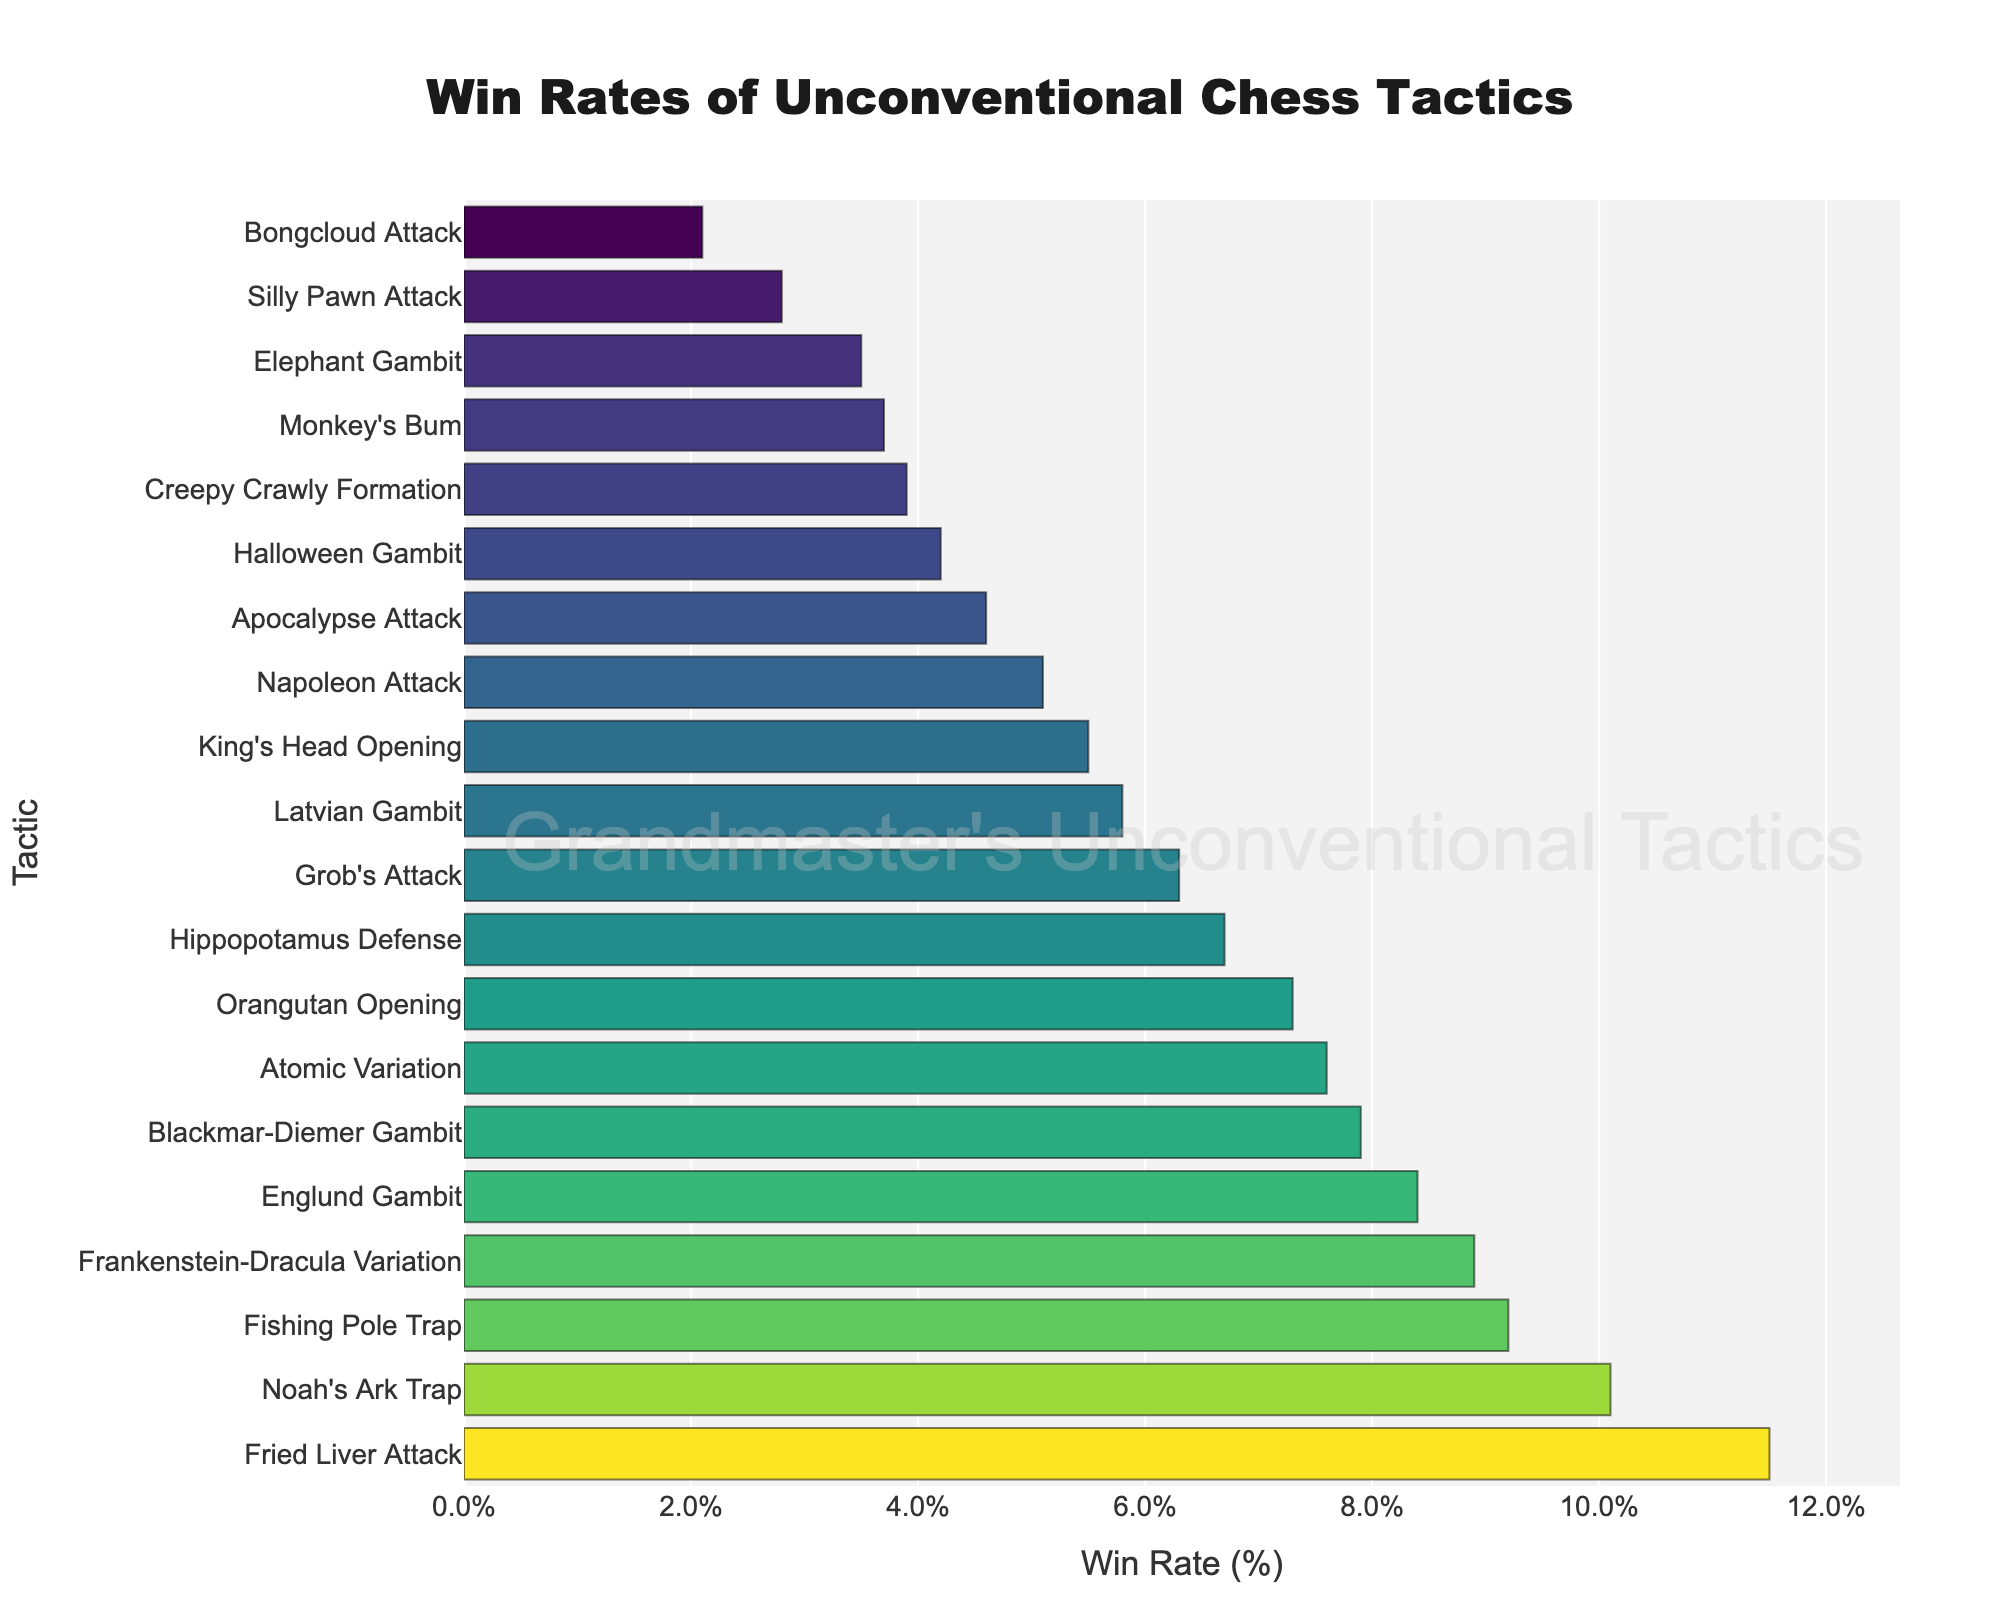Which tactic has the highest win rate? By observing the chart, we can identify the tallest bar. The Fried Liver Attack has the tallest bar, indicating it has the highest win rate among the unconventional chess tactics.
Answer: Fried Liver Attack How much higher is the win rate of Noah's Ark Trap compared to the Elephant Gambit? Locate the bars for both tactics and take note of their win rates. Noah's Ark Trap has a win rate of 10.1%, while Elephant Gambit has a win rate of 3.5%. Subtract the win rate of Elephant Gambit from Noah's Ark Trap to find the difference: 10.1% - 3.5% = 6.6%.
Answer: 6.6% What is the average win rate of Frankenstein-Dracula Variation, Atomic Variation, and Blackmar-Diemer Gambit? Identify the win rates for the three tactics: Frankenstein-Dracula Variation (8.9%), Atomic Variation (7.6%), and Blackmar-Diemer Gambit (7.9%). Sum these rates and divide by the number of rates: (8.9% + 7.6% + 7.9%) / 3 = 24.4% / 3 = 8.13%.
Answer: 8.13% Which tactic appears to have a win rate of around 8%? Analyze the chart to find any bar close to the 8% mark. The Englund Gambit has a win rate of 8.4%, which is closest to 8%.
Answer: Englund Gambit Rank the top three tactics with the highest win rates. From the chart, the top three tactics based on their win rates are: Fried Liver Attack (11.5%), Noah's Ark Trap (10.1%), and Fishing Pole Trap (9.2%).
Answer: Fried Liver Attack, Noah's Ark Trap, Fishing Pole Trap Does the Bongcloud Attack have a win rate higher or lower than 3%? Find the bar representing the Bongcloud Attack and note its win rate. The Bongcloud Attack has a win rate of 2.1%, which is lower than 3%.
Answer: Lower How many tactics have a win rate greater than 7%? Count the number of bars exceeding the 7% win rate mark. The tactics are: Blackmar-Diemer Gambit (7.9%), Englund Gambit (8.4%), Frankenstein-Dracula Variation (8.9%), Noah's Ark Trap (10.1%), Fishing Pole Trap (9.2%), and Fried Liver Attack (11.5%). There are 6 such tactics.
Answer: 6 Compare the win rates of the Hippopotamus Defense and the Monkey's Bum. Which has a higher win rate? Locate both bars in the chart and compare their win rates. The Hippopotamus Defense has a win rate of 6.7%, whereas Monkey's Bum has 3.7%. Therefore, the Hippopotamus Defense has a higher win rate.
Answer: Hippopotamus Defense What is the color gradient used to represent higher win rates in this chart? By observing the visual attributes of the bars, it's evident that the color transitions from darker tones to brighter, more intense hues as the win rate increases, indicating a gradient color scale.
Answer: Brighter hues Between which win rate range are the majority of tactics clustered? Examine the chart to identify the range where most bars are positioned. The majority of tactics appear to be in the 3% to 8% win rate range.
Answer: 3% to 8% 